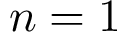<formula> <loc_0><loc_0><loc_500><loc_500>n = 1</formula> 